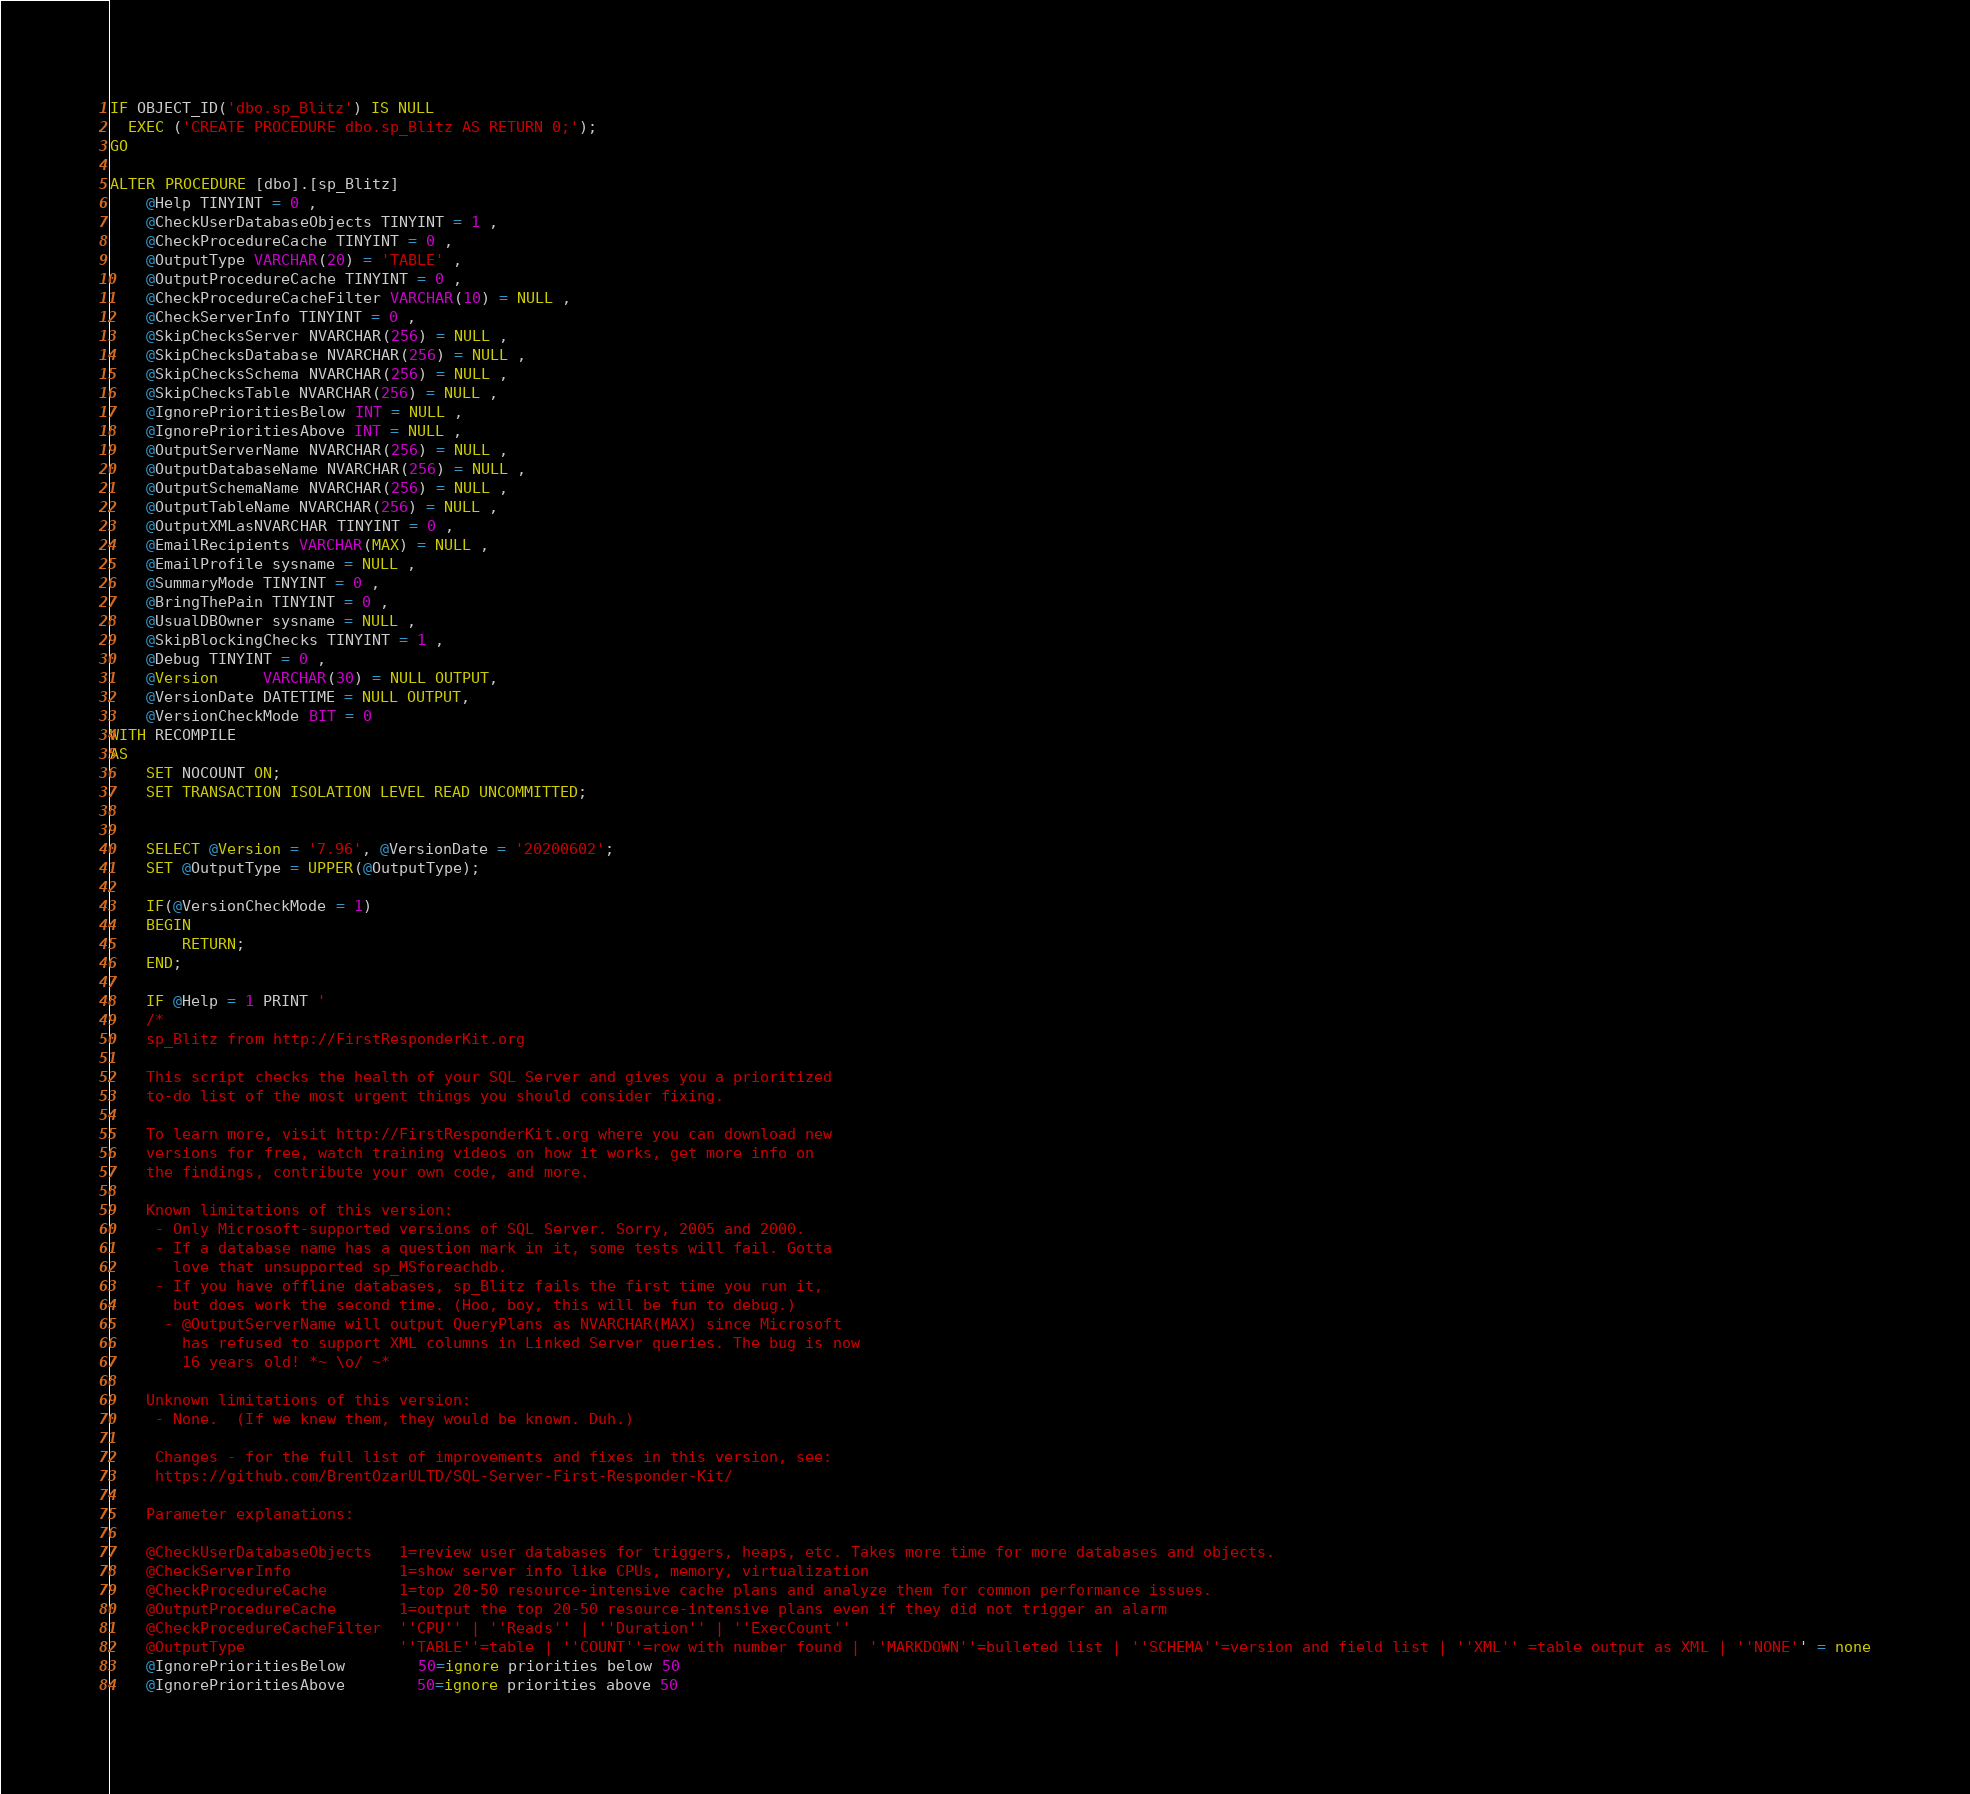<code> <loc_0><loc_0><loc_500><loc_500><_SQL_>IF OBJECT_ID('dbo.sp_Blitz') IS NULL
  EXEC ('CREATE PROCEDURE dbo.sp_Blitz AS RETURN 0;');
GO

ALTER PROCEDURE [dbo].[sp_Blitz]
    @Help TINYINT = 0 ,
    @CheckUserDatabaseObjects TINYINT = 1 ,
    @CheckProcedureCache TINYINT = 0 ,
    @OutputType VARCHAR(20) = 'TABLE' ,
    @OutputProcedureCache TINYINT = 0 ,
    @CheckProcedureCacheFilter VARCHAR(10) = NULL ,
    @CheckServerInfo TINYINT = 0 ,
    @SkipChecksServer NVARCHAR(256) = NULL ,
    @SkipChecksDatabase NVARCHAR(256) = NULL ,
    @SkipChecksSchema NVARCHAR(256) = NULL ,
    @SkipChecksTable NVARCHAR(256) = NULL ,
    @IgnorePrioritiesBelow INT = NULL ,
    @IgnorePrioritiesAbove INT = NULL ,
    @OutputServerName NVARCHAR(256) = NULL ,
    @OutputDatabaseName NVARCHAR(256) = NULL ,
    @OutputSchemaName NVARCHAR(256) = NULL ,
    @OutputTableName NVARCHAR(256) = NULL ,
    @OutputXMLasNVARCHAR TINYINT = 0 ,
    @EmailRecipients VARCHAR(MAX) = NULL ,
    @EmailProfile sysname = NULL ,
    @SummaryMode TINYINT = 0 ,
    @BringThePain TINYINT = 0 ,
    @UsualDBOwner sysname = NULL ,
	@SkipBlockingChecks TINYINT = 1 ,
    @Debug TINYINT = 0 ,
    @Version     VARCHAR(30) = NULL OUTPUT,
	@VersionDate DATETIME = NULL OUTPUT,
    @VersionCheckMode BIT = 0
WITH RECOMPILE
AS
    SET NOCOUNT ON;
	SET TRANSACTION ISOLATION LEVEL READ UNCOMMITTED;
	

	SELECT @Version = '7.96', @VersionDate = '20200602';
	SET @OutputType = UPPER(@OutputType);

    IF(@VersionCheckMode = 1)
	BEGIN
		RETURN;
	END;

	IF @Help = 1 PRINT '
	/*
	sp_Blitz from http://FirstResponderKit.org
	
	This script checks the health of your SQL Server and gives you a prioritized
	to-do list of the most urgent things you should consider fixing.

	To learn more, visit http://FirstResponderKit.org where you can download new
	versions for free, watch training videos on how it works, get more info on
	the findings, contribute your own code, and more.

	Known limitations of this version:
	 - Only Microsoft-supported versions of SQL Server. Sorry, 2005 and 2000.
	 - If a database name has a question mark in it, some tests will fail. Gotta
	   love that unsupported sp_MSforeachdb.
	 - If you have offline databases, sp_Blitz fails the first time you run it,
	   but does work the second time. (Hoo, boy, this will be fun to debug.)
      - @OutputServerName will output QueryPlans as NVARCHAR(MAX) since Microsoft
	    has refused to support XML columns in Linked Server queries. The bug is now
		16 years old! *~ \o/ ~*

	Unknown limitations of this version:
	 - None.  (If we knew them, they would be known. Duh.)

     Changes - for the full list of improvements and fixes in this version, see:
     https://github.com/BrentOzarULTD/SQL-Server-First-Responder-Kit/

	Parameter explanations:

	@CheckUserDatabaseObjects	1=review user databases for triggers, heaps, etc. Takes more time for more databases and objects.
	@CheckServerInfo			1=show server info like CPUs, memory, virtualization
	@CheckProcedureCache		1=top 20-50 resource-intensive cache plans and analyze them for common performance issues.
	@OutputProcedureCache		1=output the top 20-50 resource-intensive plans even if they did not trigger an alarm
	@CheckProcedureCacheFilter	''CPU'' | ''Reads'' | ''Duration'' | ''ExecCount''
	@OutputType					''TABLE''=table | ''COUNT''=row with number found | ''MARKDOWN''=bulleted list | ''SCHEMA''=version and field list | ''XML'' =table output as XML | ''NONE'' = none
	@IgnorePrioritiesBelow		50=ignore priorities below 50
	@IgnorePrioritiesAbove		50=ignore priorities above 50</code> 